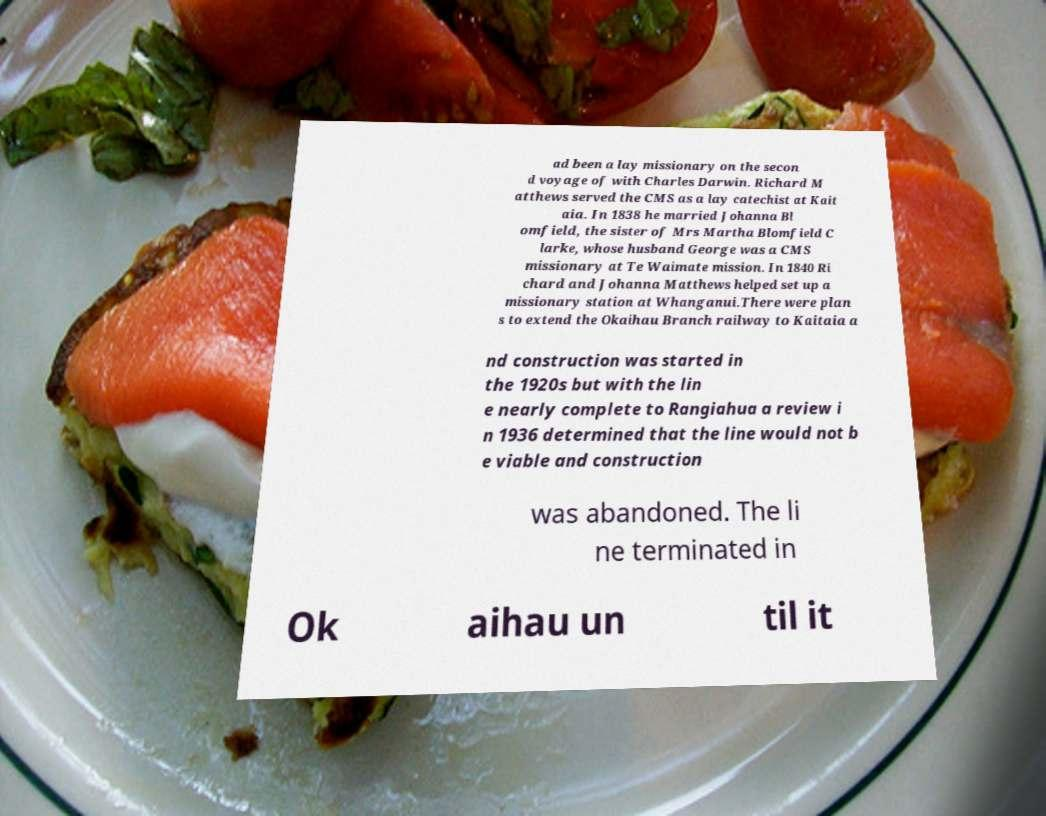Please read and relay the text visible in this image. What does it say? ad been a lay missionary on the secon d voyage of with Charles Darwin. Richard M atthews served the CMS as a lay catechist at Kait aia. In 1838 he married Johanna Bl omfield, the sister of Mrs Martha Blomfield C larke, whose husband George was a CMS missionary at Te Waimate mission. In 1840 Ri chard and Johanna Matthews helped set up a missionary station at Whanganui.There were plan s to extend the Okaihau Branch railway to Kaitaia a nd construction was started in the 1920s but with the lin e nearly complete to Rangiahua a review i n 1936 determined that the line would not b e viable and construction was abandoned. The li ne terminated in Ok aihau un til it 